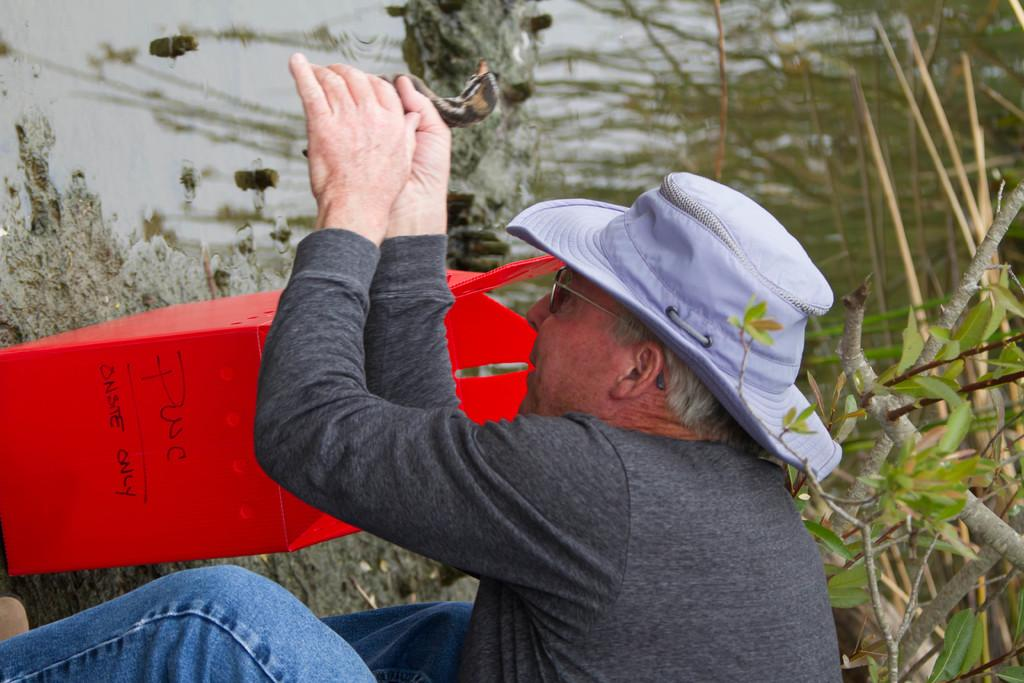What is the main subject in the foreground of the image? There is a person in the foreground of the image. What is the person holding in the image? The person is holding a bird. What can be seen in the background of the image? There is a red color object, plants, grass, and a sea visible in the background of the image. Can you see a rabbit joining the person in the image? There is no rabbit present in the image, and therefore no such interaction can be observed. 